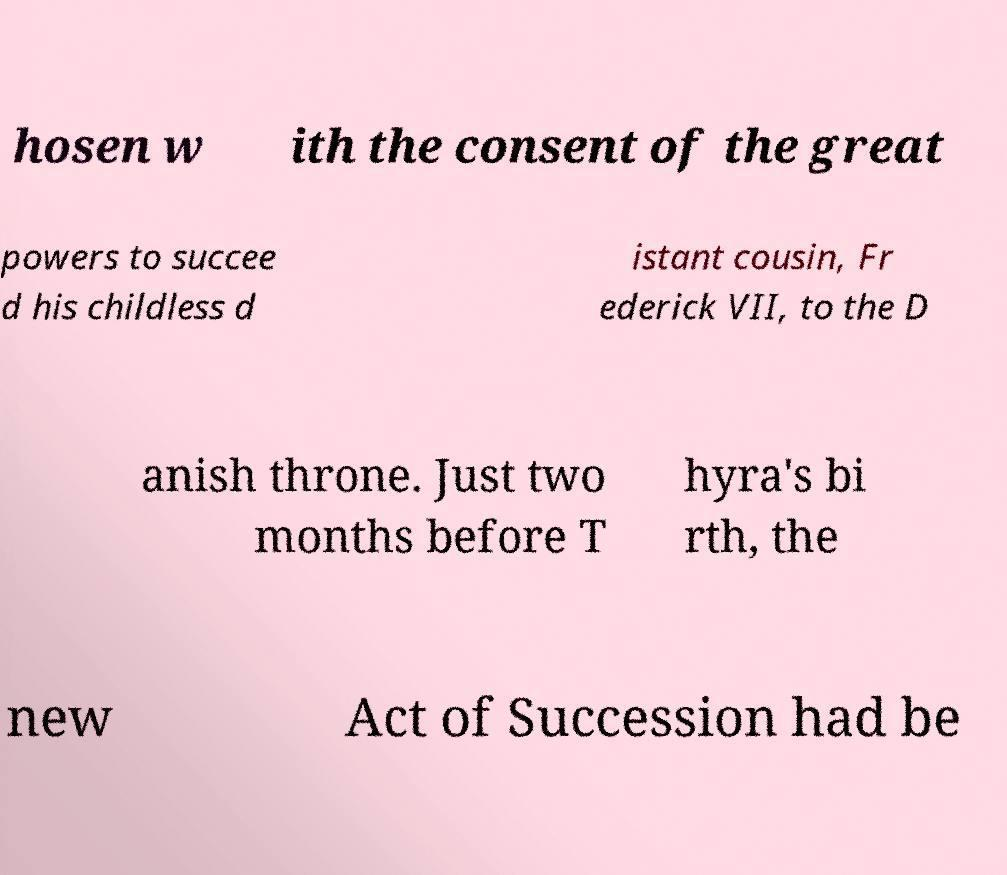Could you extract and type out the text from this image? hosen w ith the consent of the great powers to succee d his childless d istant cousin, Fr ederick VII, to the D anish throne. Just two months before T hyra's bi rth, the new Act of Succession had be 